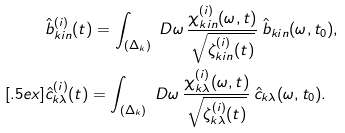Convert formula to latex. <formula><loc_0><loc_0><loc_500><loc_500>& \hat { b } ^ { ( i ) } _ { k i n } ( t ) = \int _ { ( \Delta _ { k } ) } \ D \omega \, \frac { \chi ^ { ( i ) } _ { k i n } ( \omega , t ) } { \sqrt { \zeta ^ { ( i ) } _ { k i n } ( t ) } } \, \hat { b } _ { k i n } ( \omega , t _ { 0 } ) , \\ [ . 5 e x ] & \hat { c } ^ { ( i ) } _ { k \lambda } ( t ) = \int _ { ( \Delta _ { k } ) } \ D \omega \, \frac { \chi ^ { ( i ) } _ { k \lambda } ( \omega , t ) } { \sqrt { \zeta ^ { ( i ) } _ { k \lambda } ( t ) } } \, \hat { c } _ { k \lambda } ( \omega , t _ { 0 } ) .</formula> 